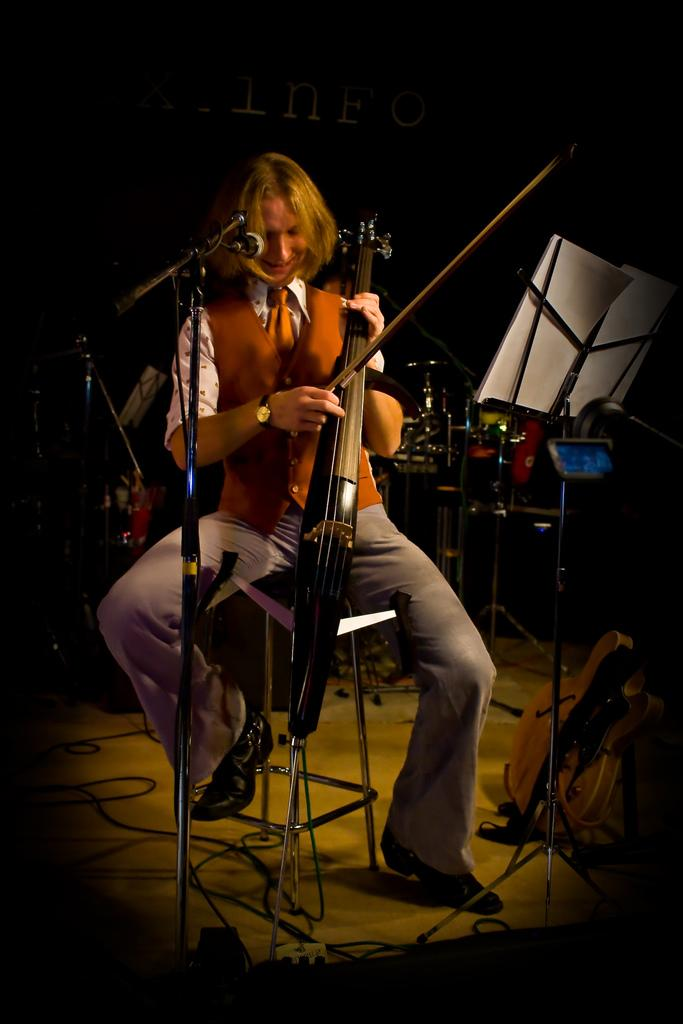What is the person in the image doing? The person is playing a musical instrument. What object is the person holding while playing the instrument? The person is holding a microphone (mike). Where is the person standing in the image? The person is standing on the floor. What can be seen in the background of the image? There are musical instruments visible in the background. What type of poison is being served on the plate in the image? There is no plate or poison present in the image. How many dimes can be seen on the floor in the image? There are no dimes visible in the image. 